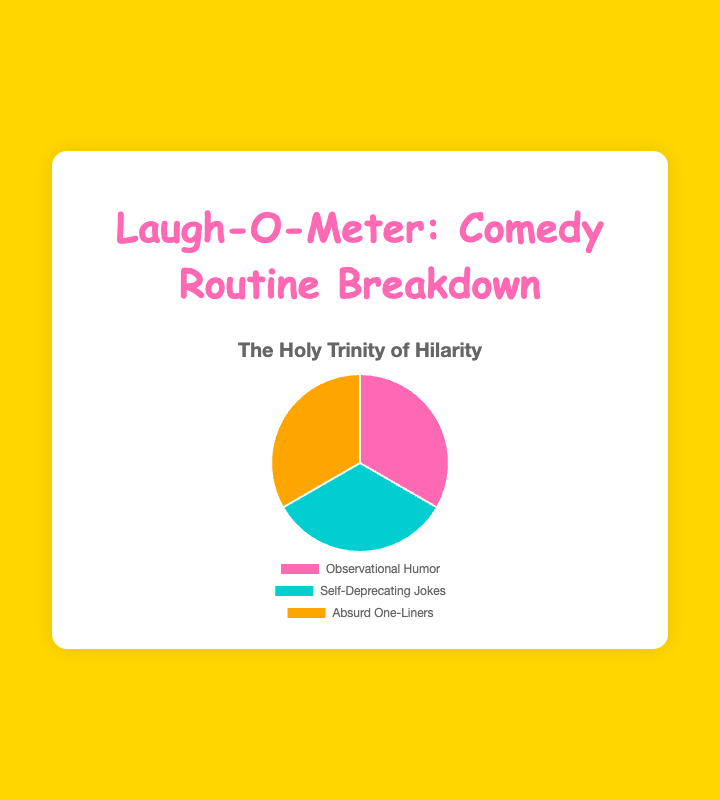which type of joke shares the same amount of examples as absurd one-liners? Observational humor and self-deprecating jokes are both shown with the same number of examples (3 examples each) as absurd one-liners, clearly indicated by their equal section sizes in the pie chart.
Answer: Observational humor and self-deprecating jokes how many total examples are shown in the pie chart? The chart contains three categories, each with 3 examples. Summing these (3 + 3 + 3) gives the total number of examples.
Answer: 9 if there were 5 examples of absurd one-liners added, what would the new total number of examples be? Adding 5 examples to the existing 9 (current total) results in the new total of 14 examples (9 + 5).
Answer: 14 is the portion of self-deprecating jokes greater than that of observational humor according to the chart? The chart shows an equal number of examples for both self-deprecating jokes and observational humor, indicated by their equal sections. Therefore, one is not greater than the other.
Answer: No what’s the ratio of observational humor to the total number of examples? The ratio is calculated by dividing the number of observational humor examples (3) by the total number of examples (9). This results in a ratio of 1:3.
Answer: 1:3 